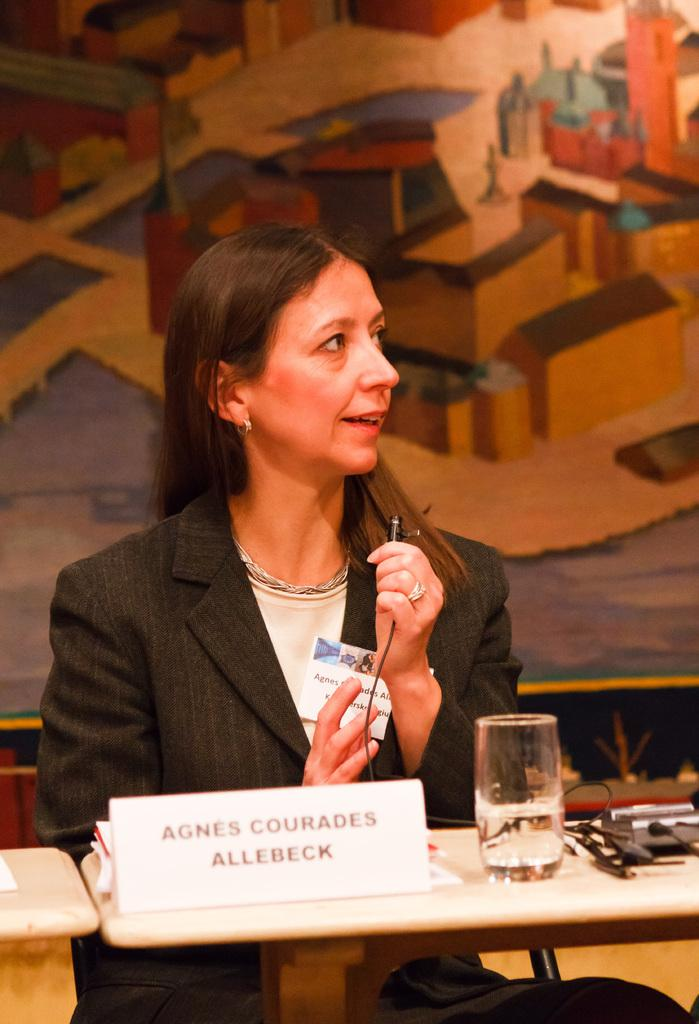Who is the main subject in the image? There is a woman in the image. What is the woman doing in the image? The woman is sitting in front of a table. What can be seen on the table in the image? A glass, a name board, and other objects are placed on the table. What is visible in the background of the image? There is a wall in the background of the image. What flavor of ice cream is the woman eating in the image? There is no ice cream present in the image, so it is not possible to determine the flavor. 